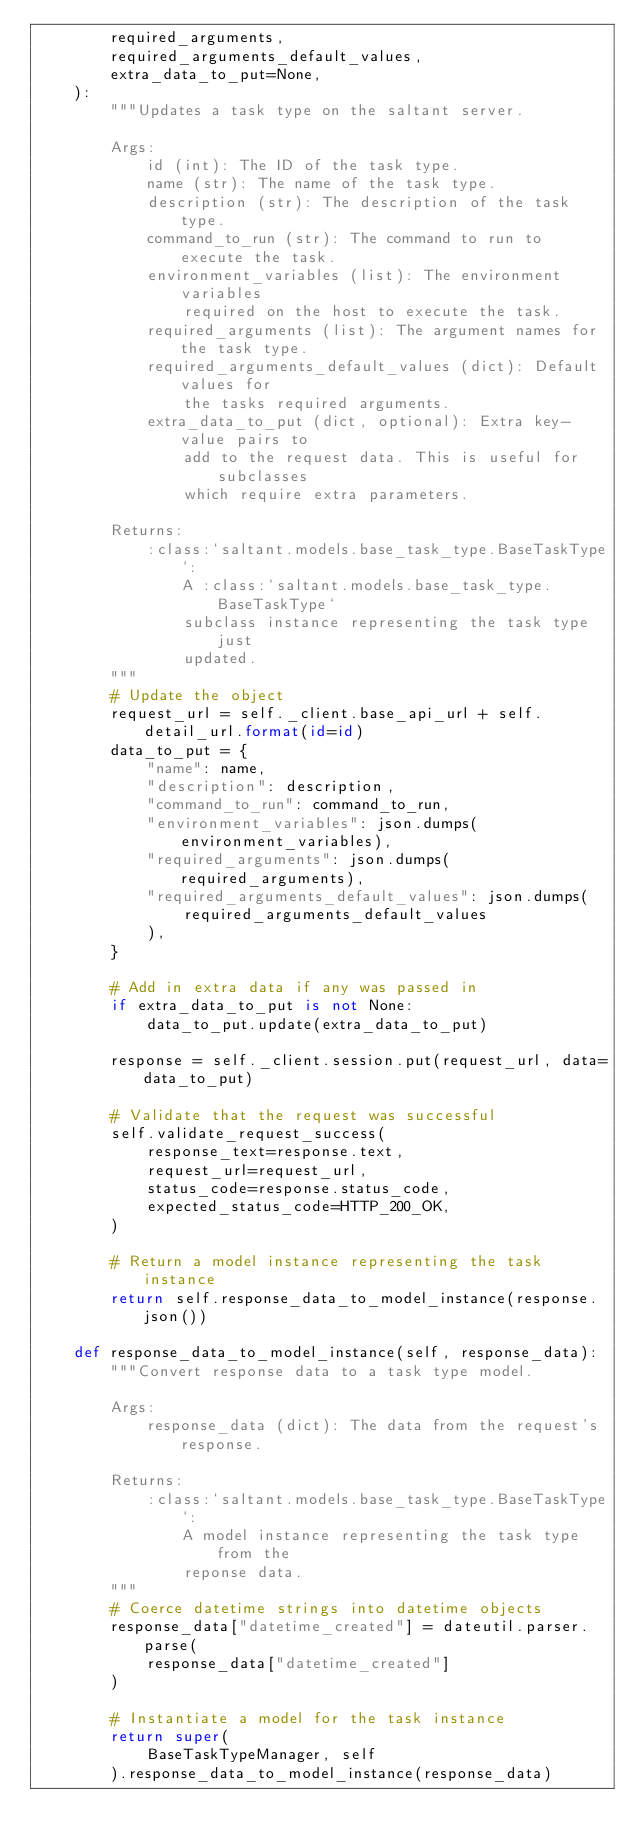<code> <loc_0><loc_0><loc_500><loc_500><_Python_>        required_arguments,
        required_arguments_default_values,
        extra_data_to_put=None,
    ):
        """Updates a task type on the saltant server.

        Args:
            id (int): The ID of the task type.
            name (str): The name of the task type.
            description (str): The description of the task type.
            command_to_run (str): The command to run to execute the task.
            environment_variables (list): The environment variables
                required on the host to execute the task.
            required_arguments (list): The argument names for the task type.
            required_arguments_default_values (dict): Default values for
                the tasks required arguments.
            extra_data_to_put (dict, optional): Extra key-value pairs to
                add to the request data. This is useful for subclasses
                which require extra parameters.

        Returns:
            :class:`saltant.models.base_task_type.BaseTaskType`:
                A :class:`saltant.models.base_task_type.BaseTaskType`
                subclass instance representing the task type just
                updated.
        """
        # Update the object
        request_url = self._client.base_api_url + self.detail_url.format(id=id)
        data_to_put = {
            "name": name,
            "description": description,
            "command_to_run": command_to_run,
            "environment_variables": json.dumps(environment_variables),
            "required_arguments": json.dumps(required_arguments),
            "required_arguments_default_values": json.dumps(
                required_arguments_default_values
            ),
        }

        # Add in extra data if any was passed in
        if extra_data_to_put is not None:
            data_to_put.update(extra_data_to_put)

        response = self._client.session.put(request_url, data=data_to_put)

        # Validate that the request was successful
        self.validate_request_success(
            response_text=response.text,
            request_url=request_url,
            status_code=response.status_code,
            expected_status_code=HTTP_200_OK,
        )

        # Return a model instance representing the task instance
        return self.response_data_to_model_instance(response.json())

    def response_data_to_model_instance(self, response_data):
        """Convert response data to a task type model.

        Args:
            response_data (dict): The data from the request's response.

        Returns:
            :class:`saltant.models.base_task_type.BaseTaskType`:
                A model instance representing the task type from the
                reponse data.
        """
        # Coerce datetime strings into datetime objects
        response_data["datetime_created"] = dateutil.parser.parse(
            response_data["datetime_created"]
        )

        # Instantiate a model for the task instance
        return super(
            BaseTaskTypeManager, self
        ).response_data_to_model_instance(response_data)
</code> 